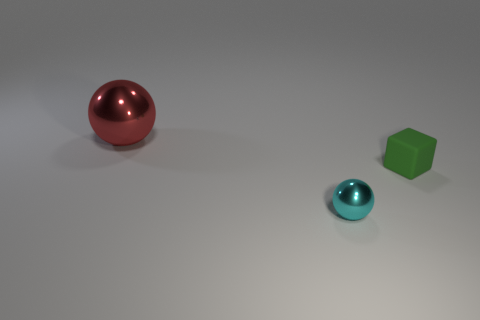Add 2 tiny metal things. How many objects exist? 5 Subtract all balls. How many objects are left? 1 Subtract 0 brown spheres. How many objects are left? 3 Subtract all big red balls. Subtract all red shiny things. How many objects are left? 1 Add 1 big balls. How many big balls are left? 2 Add 1 red balls. How many red balls exist? 2 